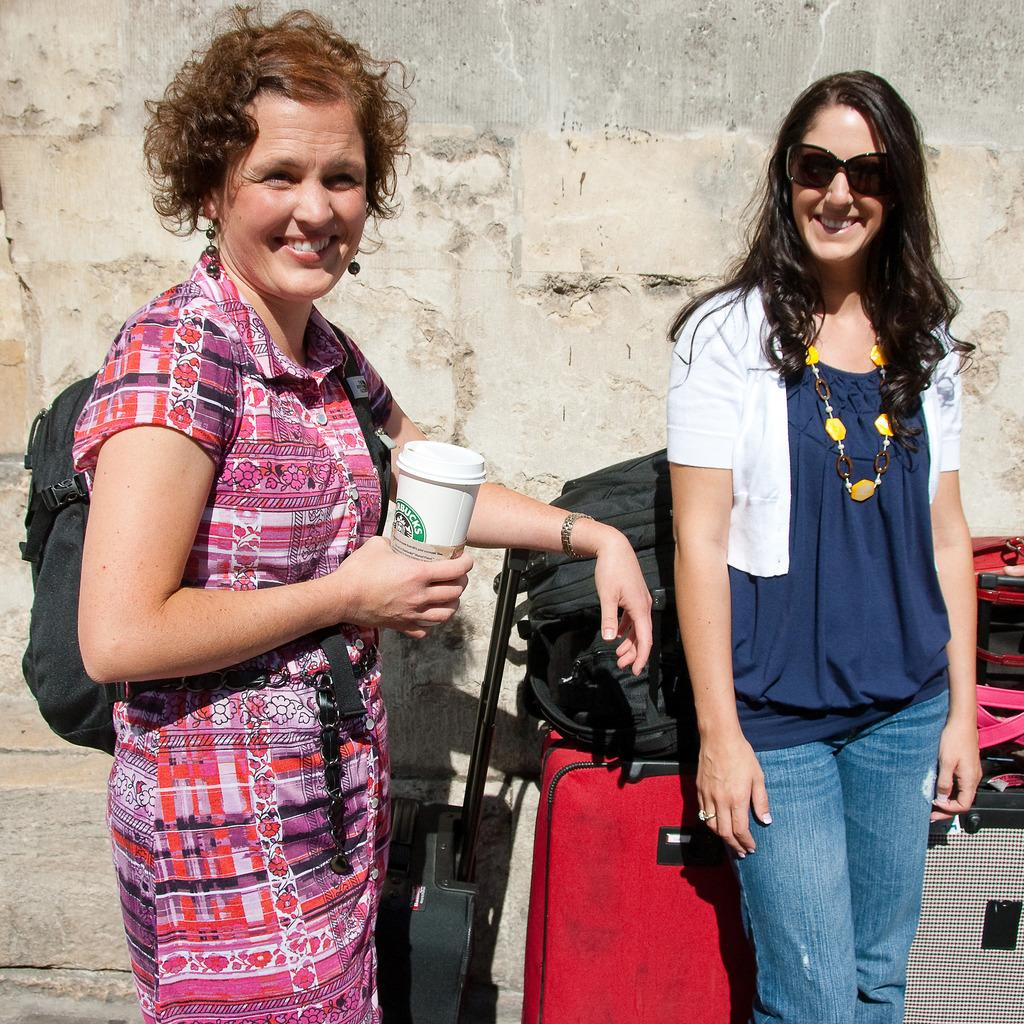How many people are in the image? There are two persons standing in the middle of the image. What are the expressions on their faces? Both persons are smiling. What is one person holding in the image? One person is holding a cup. What can be seen behind the persons? There are bags visible behind the persons. What is located at the top of the image? There is a wall at the top of the image. What type of cattle can be seen grazing in the background of the image? There is no cattle present in the image; it features two people standing and smiling. What kind of vessel is being used by the person holding the cup? The image does not show a vessel being used by the person holding the cup, only the cup itself is visible. 